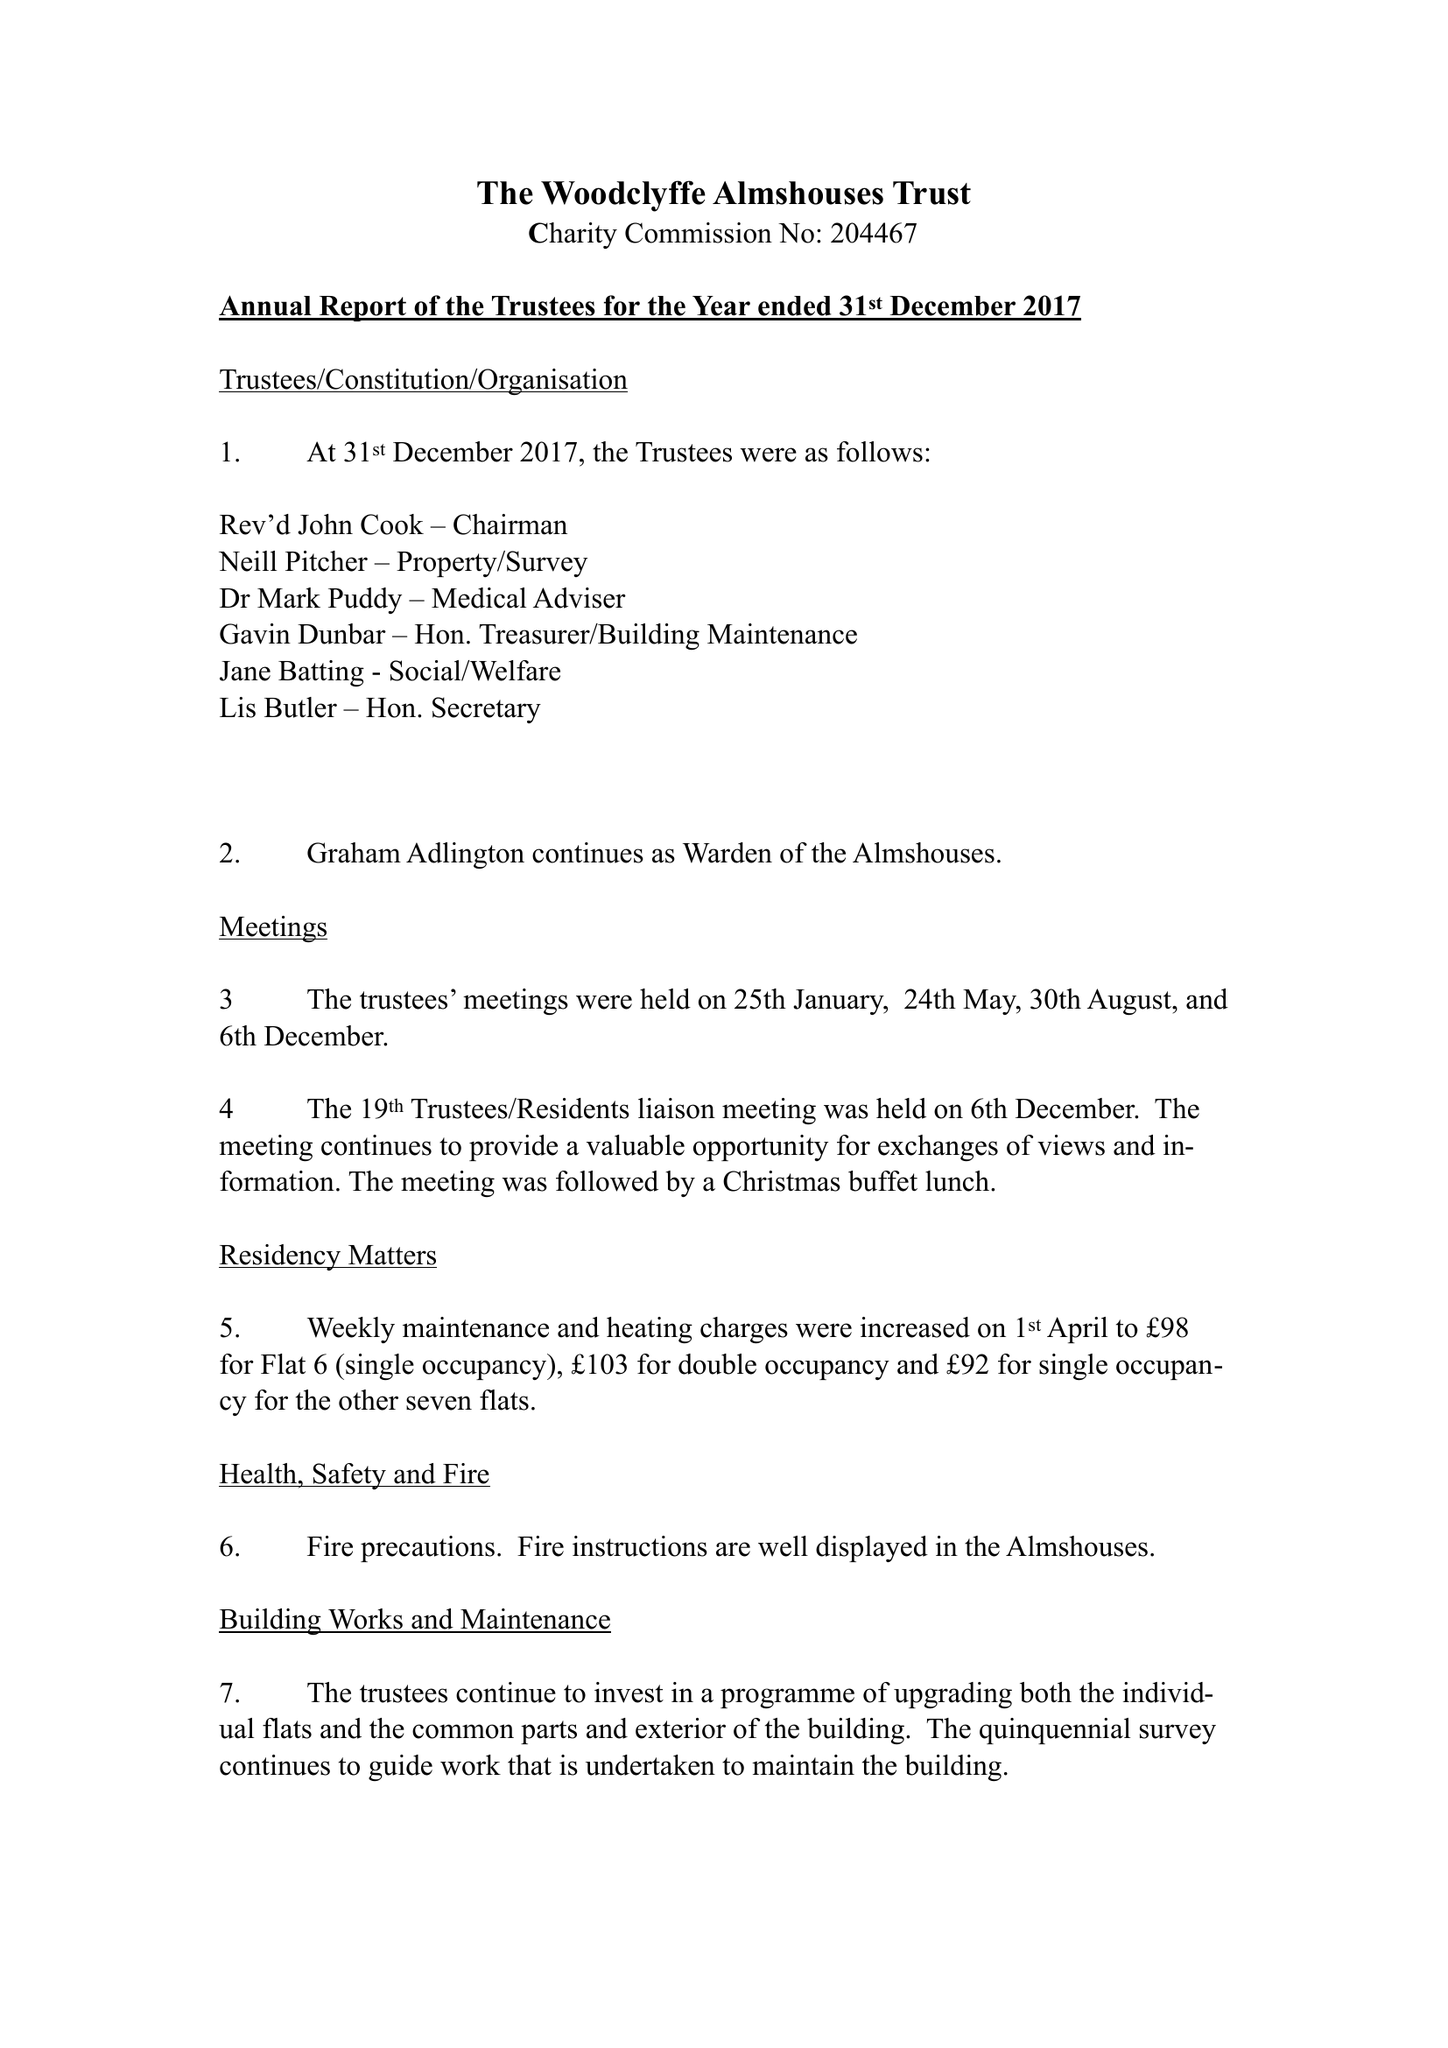What is the value for the charity_name?
Answer the question using a single word or phrase. The Woodclyffe Almshouses 